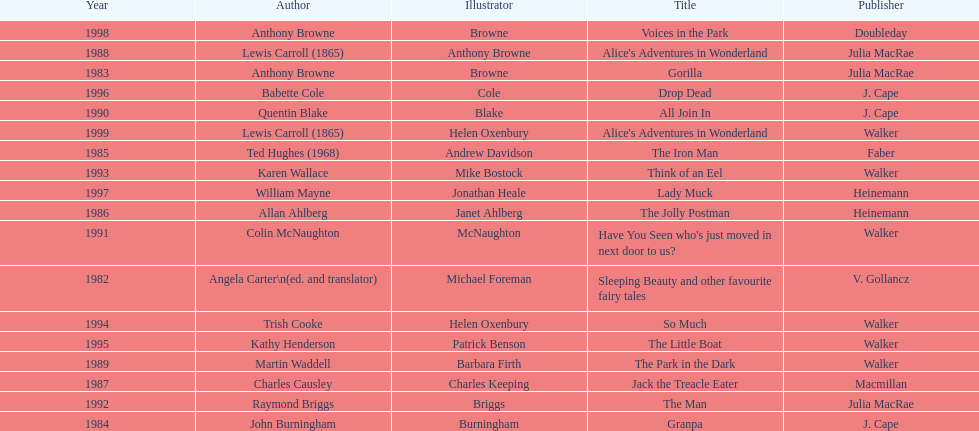How many titles had the same author listed as the illustrator? 7. 